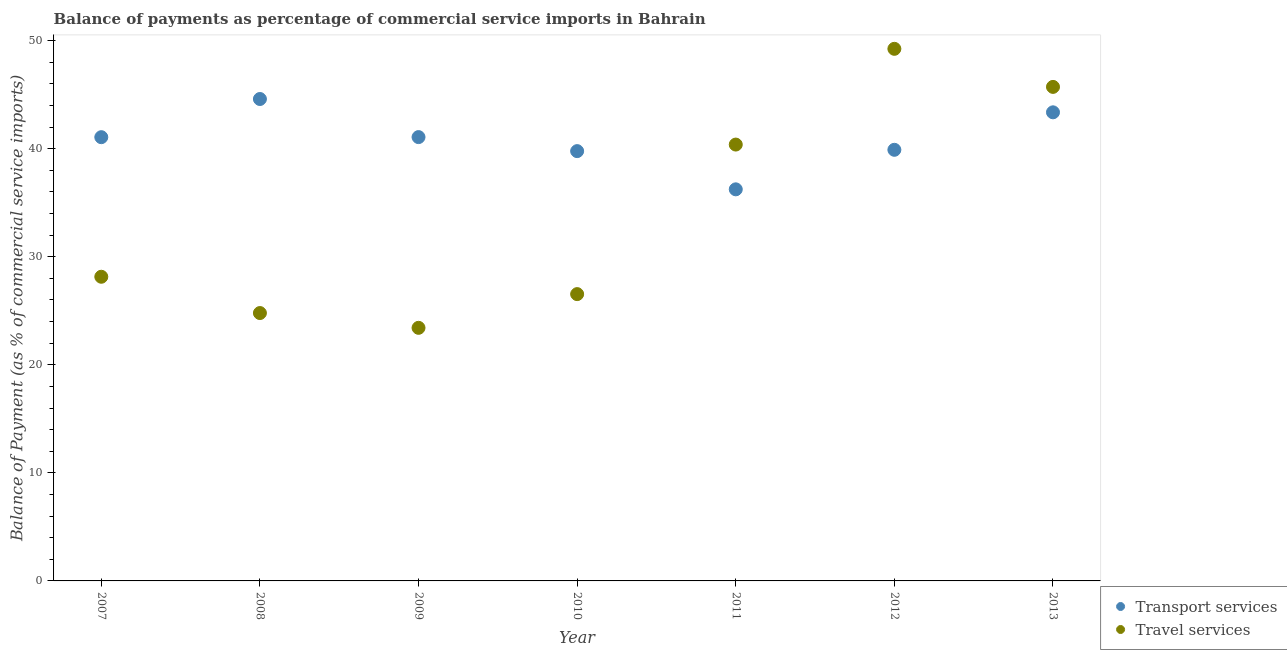How many different coloured dotlines are there?
Provide a succinct answer. 2. What is the balance of payments of transport services in 2012?
Provide a succinct answer. 39.89. Across all years, what is the maximum balance of payments of travel services?
Your answer should be very brief. 49.24. Across all years, what is the minimum balance of payments of travel services?
Your answer should be compact. 23.42. In which year was the balance of payments of transport services maximum?
Provide a short and direct response. 2008. What is the total balance of payments of travel services in the graph?
Provide a short and direct response. 238.22. What is the difference between the balance of payments of travel services in 2007 and that in 2012?
Your response must be concise. -21.09. What is the difference between the balance of payments of travel services in 2012 and the balance of payments of transport services in 2013?
Provide a succinct answer. 5.88. What is the average balance of payments of travel services per year?
Provide a succinct answer. 34.03. In the year 2010, what is the difference between the balance of payments of transport services and balance of payments of travel services?
Your response must be concise. 13.23. In how many years, is the balance of payments of travel services greater than 4 %?
Ensure brevity in your answer.  7. What is the ratio of the balance of payments of transport services in 2008 to that in 2011?
Provide a succinct answer. 1.23. Is the balance of payments of transport services in 2011 less than that in 2012?
Keep it short and to the point. Yes. What is the difference between the highest and the second highest balance of payments of transport services?
Your response must be concise. 1.23. What is the difference between the highest and the lowest balance of payments of travel services?
Your response must be concise. 25.82. In how many years, is the balance of payments of transport services greater than the average balance of payments of transport services taken over all years?
Offer a very short reply. 4. Does the balance of payments of transport services monotonically increase over the years?
Provide a short and direct response. No. How many years are there in the graph?
Ensure brevity in your answer.  7. Are the values on the major ticks of Y-axis written in scientific E-notation?
Keep it short and to the point. No. Does the graph contain any zero values?
Your answer should be compact. No. Does the graph contain grids?
Keep it short and to the point. No. How many legend labels are there?
Your response must be concise. 2. How are the legend labels stacked?
Offer a very short reply. Vertical. What is the title of the graph?
Ensure brevity in your answer.  Balance of payments as percentage of commercial service imports in Bahrain. What is the label or title of the X-axis?
Give a very brief answer. Year. What is the label or title of the Y-axis?
Your answer should be very brief. Balance of Payment (as % of commercial service imports). What is the Balance of Payment (as % of commercial service imports) of Transport services in 2007?
Make the answer very short. 41.06. What is the Balance of Payment (as % of commercial service imports) in Travel services in 2007?
Provide a short and direct response. 28.14. What is the Balance of Payment (as % of commercial service imports) of Transport services in 2008?
Make the answer very short. 44.59. What is the Balance of Payment (as % of commercial service imports) in Travel services in 2008?
Your response must be concise. 24.79. What is the Balance of Payment (as % of commercial service imports) in Transport services in 2009?
Keep it short and to the point. 41.07. What is the Balance of Payment (as % of commercial service imports) in Travel services in 2009?
Your response must be concise. 23.42. What is the Balance of Payment (as % of commercial service imports) in Transport services in 2010?
Keep it short and to the point. 39.77. What is the Balance of Payment (as % of commercial service imports) of Travel services in 2010?
Ensure brevity in your answer.  26.54. What is the Balance of Payment (as % of commercial service imports) of Transport services in 2011?
Offer a terse response. 36.23. What is the Balance of Payment (as % of commercial service imports) in Travel services in 2011?
Offer a terse response. 40.38. What is the Balance of Payment (as % of commercial service imports) of Transport services in 2012?
Your answer should be very brief. 39.89. What is the Balance of Payment (as % of commercial service imports) in Travel services in 2012?
Offer a very short reply. 49.24. What is the Balance of Payment (as % of commercial service imports) of Transport services in 2013?
Make the answer very short. 43.36. What is the Balance of Payment (as % of commercial service imports) of Travel services in 2013?
Offer a terse response. 45.71. Across all years, what is the maximum Balance of Payment (as % of commercial service imports) of Transport services?
Offer a very short reply. 44.59. Across all years, what is the maximum Balance of Payment (as % of commercial service imports) of Travel services?
Your answer should be compact. 49.24. Across all years, what is the minimum Balance of Payment (as % of commercial service imports) in Transport services?
Provide a succinct answer. 36.23. Across all years, what is the minimum Balance of Payment (as % of commercial service imports) in Travel services?
Provide a succinct answer. 23.42. What is the total Balance of Payment (as % of commercial service imports) of Transport services in the graph?
Your answer should be very brief. 285.98. What is the total Balance of Payment (as % of commercial service imports) in Travel services in the graph?
Ensure brevity in your answer.  238.22. What is the difference between the Balance of Payment (as % of commercial service imports) in Transport services in 2007 and that in 2008?
Offer a very short reply. -3.53. What is the difference between the Balance of Payment (as % of commercial service imports) of Travel services in 2007 and that in 2008?
Offer a terse response. 3.36. What is the difference between the Balance of Payment (as % of commercial service imports) in Transport services in 2007 and that in 2009?
Offer a terse response. -0.01. What is the difference between the Balance of Payment (as % of commercial service imports) in Travel services in 2007 and that in 2009?
Keep it short and to the point. 4.73. What is the difference between the Balance of Payment (as % of commercial service imports) of Transport services in 2007 and that in 2010?
Ensure brevity in your answer.  1.29. What is the difference between the Balance of Payment (as % of commercial service imports) in Travel services in 2007 and that in 2010?
Give a very brief answer. 1.61. What is the difference between the Balance of Payment (as % of commercial service imports) in Transport services in 2007 and that in 2011?
Ensure brevity in your answer.  4.83. What is the difference between the Balance of Payment (as % of commercial service imports) of Travel services in 2007 and that in 2011?
Provide a succinct answer. -12.23. What is the difference between the Balance of Payment (as % of commercial service imports) of Transport services in 2007 and that in 2012?
Keep it short and to the point. 1.17. What is the difference between the Balance of Payment (as % of commercial service imports) of Travel services in 2007 and that in 2012?
Provide a short and direct response. -21.09. What is the difference between the Balance of Payment (as % of commercial service imports) of Transport services in 2007 and that in 2013?
Your answer should be compact. -2.3. What is the difference between the Balance of Payment (as % of commercial service imports) in Travel services in 2007 and that in 2013?
Keep it short and to the point. -17.57. What is the difference between the Balance of Payment (as % of commercial service imports) of Transport services in 2008 and that in 2009?
Offer a terse response. 3.53. What is the difference between the Balance of Payment (as % of commercial service imports) of Travel services in 2008 and that in 2009?
Make the answer very short. 1.37. What is the difference between the Balance of Payment (as % of commercial service imports) of Transport services in 2008 and that in 2010?
Your answer should be compact. 4.82. What is the difference between the Balance of Payment (as % of commercial service imports) in Travel services in 2008 and that in 2010?
Your response must be concise. -1.75. What is the difference between the Balance of Payment (as % of commercial service imports) of Transport services in 2008 and that in 2011?
Offer a terse response. 8.36. What is the difference between the Balance of Payment (as % of commercial service imports) in Travel services in 2008 and that in 2011?
Your answer should be compact. -15.59. What is the difference between the Balance of Payment (as % of commercial service imports) of Transport services in 2008 and that in 2012?
Ensure brevity in your answer.  4.7. What is the difference between the Balance of Payment (as % of commercial service imports) in Travel services in 2008 and that in 2012?
Give a very brief answer. -24.45. What is the difference between the Balance of Payment (as % of commercial service imports) of Transport services in 2008 and that in 2013?
Offer a terse response. 1.23. What is the difference between the Balance of Payment (as % of commercial service imports) in Travel services in 2008 and that in 2013?
Provide a short and direct response. -20.93. What is the difference between the Balance of Payment (as % of commercial service imports) in Transport services in 2009 and that in 2010?
Your answer should be compact. 1.3. What is the difference between the Balance of Payment (as % of commercial service imports) in Travel services in 2009 and that in 2010?
Offer a terse response. -3.12. What is the difference between the Balance of Payment (as % of commercial service imports) in Transport services in 2009 and that in 2011?
Keep it short and to the point. 4.83. What is the difference between the Balance of Payment (as % of commercial service imports) in Travel services in 2009 and that in 2011?
Offer a terse response. -16.96. What is the difference between the Balance of Payment (as % of commercial service imports) of Transport services in 2009 and that in 2012?
Your answer should be compact. 1.18. What is the difference between the Balance of Payment (as % of commercial service imports) in Travel services in 2009 and that in 2012?
Ensure brevity in your answer.  -25.82. What is the difference between the Balance of Payment (as % of commercial service imports) in Transport services in 2009 and that in 2013?
Ensure brevity in your answer.  -2.29. What is the difference between the Balance of Payment (as % of commercial service imports) of Travel services in 2009 and that in 2013?
Make the answer very short. -22.29. What is the difference between the Balance of Payment (as % of commercial service imports) in Transport services in 2010 and that in 2011?
Give a very brief answer. 3.54. What is the difference between the Balance of Payment (as % of commercial service imports) in Travel services in 2010 and that in 2011?
Ensure brevity in your answer.  -13.84. What is the difference between the Balance of Payment (as % of commercial service imports) in Transport services in 2010 and that in 2012?
Offer a very short reply. -0.12. What is the difference between the Balance of Payment (as % of commercial service imports) in Travel services in 2010 and that in 2012?
Keep it short and to the point. -22.7. What is the difference between the Balance of Payment (as % of commercial service imports) in Transport services in 2010 and that in 2013?
Offer a terse response. -3.59. What is the difference between the Balance of Payment (as % of commercial service imports) in Travel services in 2010 and that in 2013?
Keep it short and to the point. -19.17. What is the difference between the Balance of Payment (as % of commercial service imports) in Transport services in 2011 and that in 2012?
Your answer should be compact. -3.66. What is the difference between the Balance of Payment (as % of commercial service imports) of Travel services in 2011 and that in 2012?
Your response must be concise. -8.86. What is the difference between the Balance of Payment (as % of commercial service imports) of Transport services in 2011 and that in 2013?
Provide a short and direct response. -7.13. What is the difference between the Balance of Payment (as % of commercial service imports) in Travel services in 2011 and that in 2013?
Give a very brief answer. -5.34. What is the difference between the Balance of Payment (as % of commercial service imports) of Transport services in 2012 and that in 2013?
Offer a terse response. -3.47. What is the difference between the Balance of Payment (as % of commercial service imports) in Travel services in 2012 and that in 2013?
Provide a succinct answer. 3.52. What is the difference between the Balance of Payment (as % of commercial service imports) of Transport services in 2007 and the Balance of Payment (as % of commercial service imports) of Travel services in 2008?
Offer a very short reply. 16.27. What is the difference between the Balance of Payment (as % of commercial service imports) of Transport services in 2007 and the Balance of Payment (as % of commercial service imports) of Travel services in 2009?
Offer a very short reply. 17.64. What is the difference between the Balance of Payment (as % of commercial service imports) of Transport services in 2007 and the Balance of Payment (as % of commercial service imports) of Travel services in 2010?
Ensure brevity in your answer.  14.52. What is the difference between the Balance of Payment (as % of commercial service imports) in Transport services in 2007 and the Balance of Payment (as % of commercial service imports) in Travel services in 2011?
Give a very brief answer. 0.68. What is the difference between the Balance of Payment (as % of commercial service imports) in Transport services in 2007 and the Balance of Payment (as % of commercial service imports) in Travel services in 2012?
Make the answer very short. -8.18. What is the difference between the Balance of Payment (as % of commercial service imports) of Transport services in 2007 and the Balance of Payment (as % of commercial service imports) of Travel services in 2013?
Provide a succinct answer. -4.65. What is the difference between the Balance of Payment (as % of commercial service imports) in Transport services in 2008 and the Balance of Payment (as % of commercial service imports) in Travel services in 2009?
Offer a terse response. 21.17. What is the difference between the Balance of Payment (as % of commercial service imports) in Transport services in 2008 and the Balance of Payment (as % of commercial service imports) in Travel services in 2010?
Ensure brevity in your answer.  18.05. What is the difference between the Balance of Payment (as % of commercial service imports) of Transport services in 2008 and the Balance of Payment (as % of commercial service imports) of Travel services in 2011?
Provide a succinct answer. 4.22. What is the difference between the Balance of Payment (as % of commercial service imports) of Transport services in 2008 and the Balance of Payment (as % of commercial service imports) of Travel services in 2012?
Offer a terse response. -4.64. What is the difference between the Balance of Payment (as % of commercial service imports) in Transport services in 2008 and the Balance of Payment (as % of commercial service imports) in Travel services in 2013?
Offer a very short reply. -1.12. What is the difference between the Balance of Payment (as % of commercial service imports) in Transport services in 2009 and the Balance of Payment (as % of commercial service imports) in Travel services in 2010?
Offer a terse response. 14.53. What is the difference between the Balance of Payment (as % of commercial service imports) in Transport services in 2009 and the Balance of Payment (as % of commercial service imports) in Travel services in 2011?
Your answer should be very brief. 0.69. What is the difference between the Balance of Payment (as % of commercial service imports) of Transport services in 2009 and the Balance of Payment (as % of commercial service imports) of Travel services in 2012?
Your answer should be compact. -8.17. What is the difference between the Balance of Payment (as % of commercial service imports) in Transport services in 2009 and the Balance of Payment (as % of commercial service imports) in Travel services in 2013?
Offer a terse response. -4.65. What is the difference between the Balance of Payment (as % of commercial service imports) in Transport services in 2010 and the Balance of Payment (as % of commercial service imports) in Travel services in 2011?
Offer a terse response. -0.61. What is the difference between the Balance of Payment (as % of commercial service imports) in Transport services in 2010 and the Balance of Payment (as % of commercial service imports) in Travel services in 2012?
Offer a very short reply. -9.47. What is the difference between the Balance of Payment (as % of commercial service imports) of Transport services in 2010 and the Balance of Payment (as % of commercial service imports) of Travel services in 2013?
Give a very brief answer. -5.94. What is the difference between the Balance of Payment (as % of commercial service imports) of Transport services in 2011 and the Balance of Payment (as % of commercial service imports) of Travel services in 2012?
Ensure brevity in your answer.  -13. What is the difference between the Balance of Payment (as % of commercial service imports) in Transport services in 2011 and the Balance of Payment (as % of commercial service imports) in Travel services in 2013?
Give a very brief answer. -9.48. What is the difference between the Balance of Payment (as % of commercial service imports) in Transport services in 2012 and the Balance of Payment (as % of commercial service imports) in Travel services in 2013?
Make the answer very short. -5.82. What is the average Balance of Payment (as % of commercial service imports) of Transport services per year?
Your response must be concise. 40.85. What is the average Balance of Payment (as % of commercial service imports) in Travel services per year?
Make the answer very short. 34.03. In the year 2007, what is the difference between the Balance of Payment (as % of commercial service imports) in Transport services and Balance of Payment (as % of commercial service imports) in Travel services?
Offer a terse response. 12.92. In the year 2008, what is the difference between the Balance of Payment (as % of commercial service imports) of Transport services and Balance of Payment (as % of commercial service imports) of Travel services?
Give a very brief answer. 19.81. In the year 2009, what is the difference between the Balance of Payment (as % of commercial service imports) in Transport services and Balance of Payment (as % of commercial service imports) in Travel services?
Your answer should be very brief. 17.65. In the year 2010, what is the difference between the Balance of Payment (as % of commercial service imports) of Transport services and Balance of Payment (as % of commercial service imports) of Travel services?
Your answer should be very brief. 13.23. In the year 2011, what is the difference between the Balance of Payment (as % of commercial service imports) in Transport services and Balance of Payment (as % of commercial service imports) in Travel services?
Keep it short and to the point. -4.14. In the year 2012, what is the difference between the Balance of Payment (as % of commercial service imports) of Transport services and Balance of Payment (as % of commercial service imports) of Travel services?
Your answer should be compact. -9.34. In the year 2013, what is the difference between the Balance of Payment (as % of commercial service imports) in Transport services and Balance of Payment (as % of commercial service imports) in Travel services?
Your answer should be compact. -2.35. What is the ratio of the Balance of Payment (as % of commercial service imports) in Transport services in 2007 to that in 2008?
Your answer should be very brief. 0.92. What is the ratio of the Balance of Payment (as % of commercial service imports) in Travel services in 2007 to that in 2008?
Keep it short and to the point. 1.14. What is the ratio of the Balance of Payment (as % of commercial service imports) of Travel services in 2007 to that in 2009?
Keep it short and to the point. 1.2. What is the ratio of the Balance of Payment (as % of commercial service imports) of Transport services in 2007 to that in 2010?
Offer a very short reply. 1.03. What is the ratio of the Balance of Payment (as % of commercial service imports) in Travel services in 2007 to that in 2010?
Make the answer very short. 1.06. What is the ratio of the Balance of Payment (as % of commercial service imports) in Transport services in 2007 to that in 2011?
Offer a very short reply. 1.13. What is the ratio of the Balance of Payment (as % of commercial service imports) in Travel services in 2007 to that in 2011?
Provide a succinct answer. 0.7. What is the ratio of the Balance of Payment (as % of commercial service imports) in Transport services in 2007 to that in 2012?
Give a very brief answer. 1.03. What is the ratio of the Balance of Payment (as % of commercial service imports) in Travel services in 2007 to that in 2012?
Your answer should be compact. 0.57. What is the ratio of the Balance of Payment (as % of commercial service imports) in Transport services in 2007 to that in 2013?
Make the answer very short. 0.95. What is the ratio of the Balance of Payment (as % of commercial service imports) in Travel services in 2007 to that in 2013?
Offer a terse response. 0.62. What is the ratio of the Balance of Payment (as % of commercial service imports) of Transport services in 2008 to that in 2009?
Provide a succinct answer. 1.09. What is the ratio of the Balance of Payment (as % of commercial service imports) of Travel services in 2008 to that in 2009?
Provide a succinct answer. 1.06. What is the ratio of the Balance of Payment (as % of commercial service imports) in Transport services in 2008 to that in 2010?
Keep it short and to the point. 1.12. What is the ratio of the Balance of Payment (as % of commercial service imports) in Travel services in 2008 to that in 2010?
Keep it short and to the point. 0.93. What is the ratio of the Balance of Payment (as % of commercial service imports) in Transport services in 2008 to that in 2011?
Your response must be concise. 1.23. What is the ratio of the Balance of Payment (as % of commercial service imports) of Travel services in 2008 to that in 2011?
Offer a very short reply. 0.61. What is the ratio of the Balance of Payment (as % of commercial service imports) of Transport services in 2008 to that in 2012?
Your answer should be compact. 1.12. What is the ratio of the Balance of Payment (as % of commercial service imports) in Travel services in 2008 to that in 2012?
Give a very brief answer. 0.5. What is the ratio of the Balance of Payment (as % of commercial service imports) in Transport services in 2008 to that in 2013?
Provide a succinct answer. 1.03. What is the ratio of the Balance of Payment (as % of commercial service imports) in Travel services in 2008 to that in 2013?
Make the answer very short. 0.54. What is the ratio of the Balance of Payment (as % of commercial service imports) in Transport services in 2009 to that in 2010?
Provide a short and direct response. 1.03. What is the ratio of the Balance of Payment (as % of commercial service imports) in Travel services in 2009 to that in 2010?
Your answer should be very brief. 0.88. What is the ratio of the Balance of Payment (as % of commercial service imports) in Transport services in 2009 to that in 2011?
Your response must be concise. 1.13. What is the ratio of the Balance of Payment (as % of commercial service imports) in Travel services in 2009 to that in 2011?
Give a very brief answer. 0.58. What is the ratio of the Balance of Payment (as % of commercial service imports) of Transport services in 2009 to that in 2012?
Your answer should be very brief. 1.03. What is the ratio of the Balance of Payment (as % of commercial service imports) in Travel services in 2009 to that in 2012?
Make the answer very short. 0.48. What is the ratio of the Balance of Payment (as % of commercial service imports) in Transport services in 2009 to that in 2013?
Ensure brevity in your answer.  0.95. What is the ratio of the Balance of Payment (as % of commercial service imports) in Travel services in 2009 to that in 2013?
Your answer should be very brief. 0.51. What is the ratio of the Balance of Payment (as % of commercial service imports) in Transport services in 2010 to that in 2011?
Offer a very short reply. 1.1. What is the ratio of the Balance of Payment (as % of commercial service imports) in Travel services in 2010 to that in 2011?
Give a very brief answer. 0.66. What is the ratio of the Balance of Payment (as % of commercial service imports) in Travel services in 2010 to that in 2012?
Keep it short and to the point. 0.54. What is the ratio of the Balance of Payment (as % of commercial service imports) of Transport services in 2010 to that in 2013?
Give a very brief answer. 0.92. What is the ratio of the Balance of Payment (as % of commercial service imports) of Travel services in 2010 to that in 2013?
Offer a very short reply. 0.58. What is the ratio of the Balance of Payment (as % of commercial service imports) of Transport services in 2011 to that in 2012?
Your answer should be very brief. 0.91. What is the ratio of the Balance of Payment (as % of commercial service imports) of Travel services in 2011 to that in 2012?
Make the answer very short. 0.82. What is the ratio of the Balance of Payment (as % of commercial service imports) of Transport services in 2011 to that in 2013?
Provide a short and direct response. 0.84. What is the ratio of the Balance of Payment (as % of commercial service imports) in Travel services in 2011 to that in 2013?
Make the answer very short. 0.88. What is the ratio of the Balance of Payment (as % of commercial service imports) in Transport services in 2012 to that in 2013?
Ensure brevity in your answer.  0.92. What is the ratio of the Balance of Payment (as % of commercial service imports) in Travel services in 2012 to that in 2013?
Provide a succinct answer. 1.08. What is the difference between the highest and the second highest Balance of Payment (as % of commercial service imports) of Transport services?
Keep it short and to the point. 1.23. What is the difference between the highest and the second highest Balance of Payment (as % of commercial service imports) in Travel services?
Your answer should be very brief. 3.52. What is the difference between the highest and the lowest Balance of Payment (as % of commercial service imports) in Transport services?
Keep it short and to the point. 8.36. What is the difference between the highest and the lowest Balance of Payment (as % of commercial service imports) in Travel services?
Make the answer very short. 25.82. 